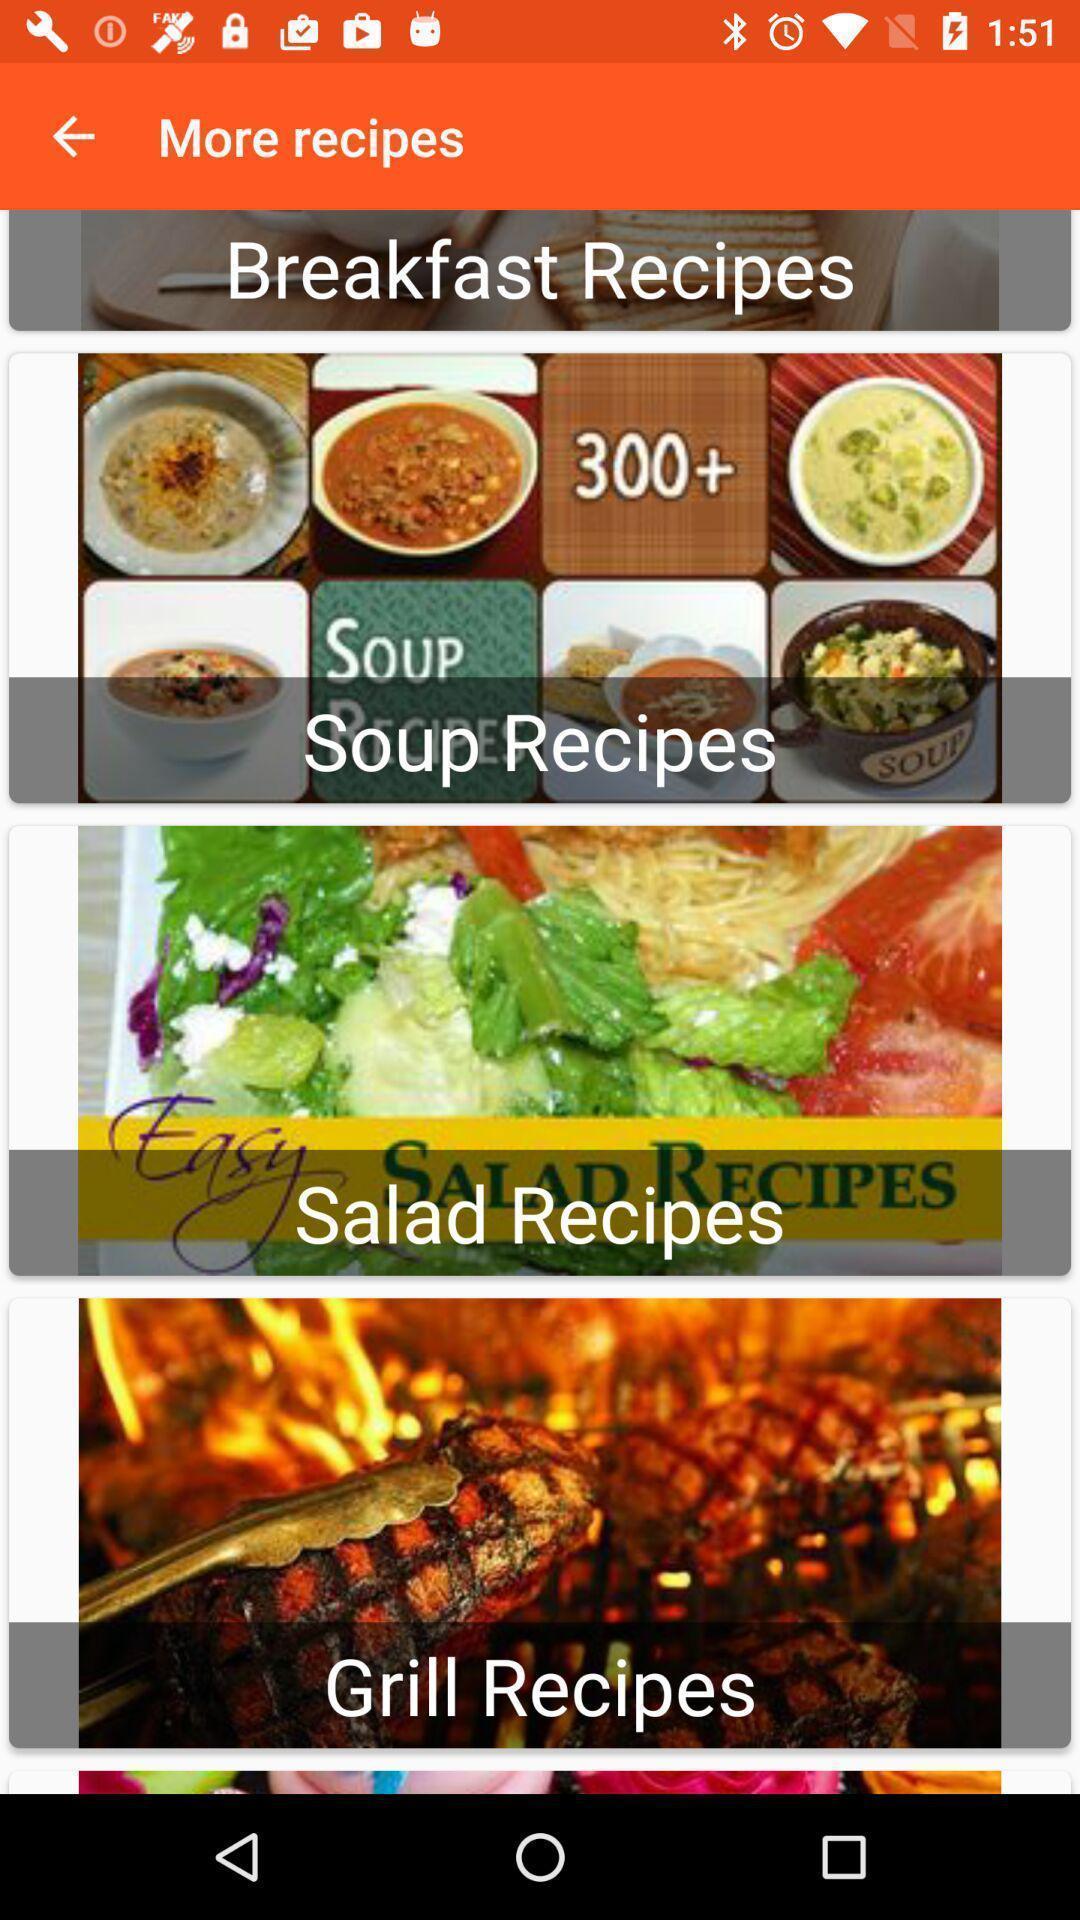Explain the elements present in this screenshot. Various recipes images displayed of a cooking app. 